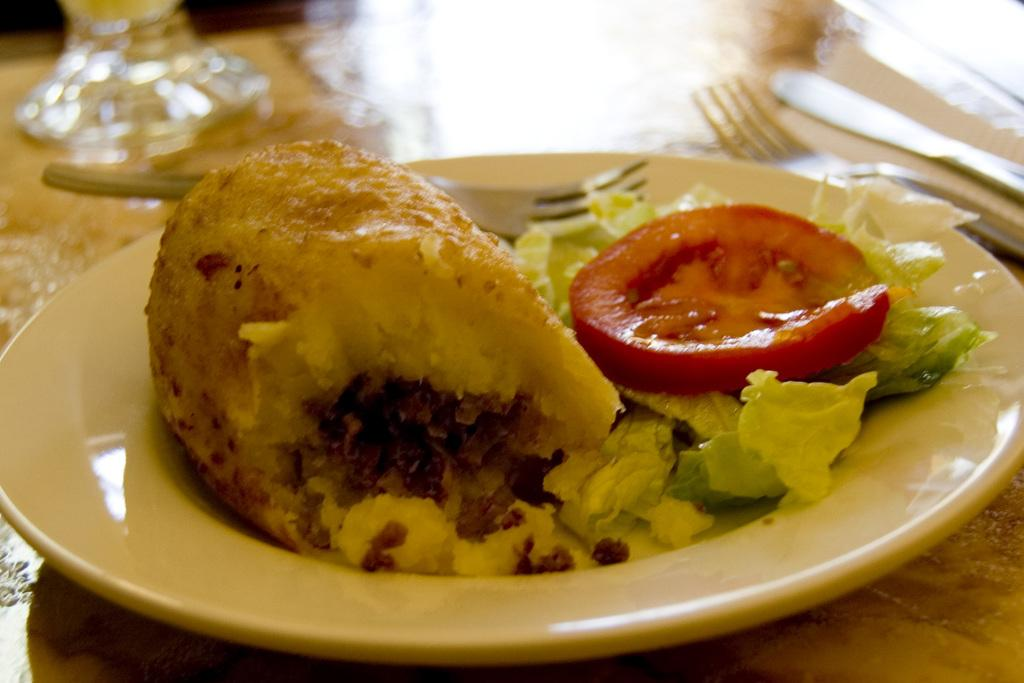What type of food can be seen in the image? The food in the image has brown, green, and red colors. How is the food arranged in the image? The food is on a plate in the image. What color is the plate? The plate is white. How many utensils are visible in the image? There are two forks in the image. What type of toys are displayed on the plate in the image? There are no toys present on the plate in the image; it contains food. 